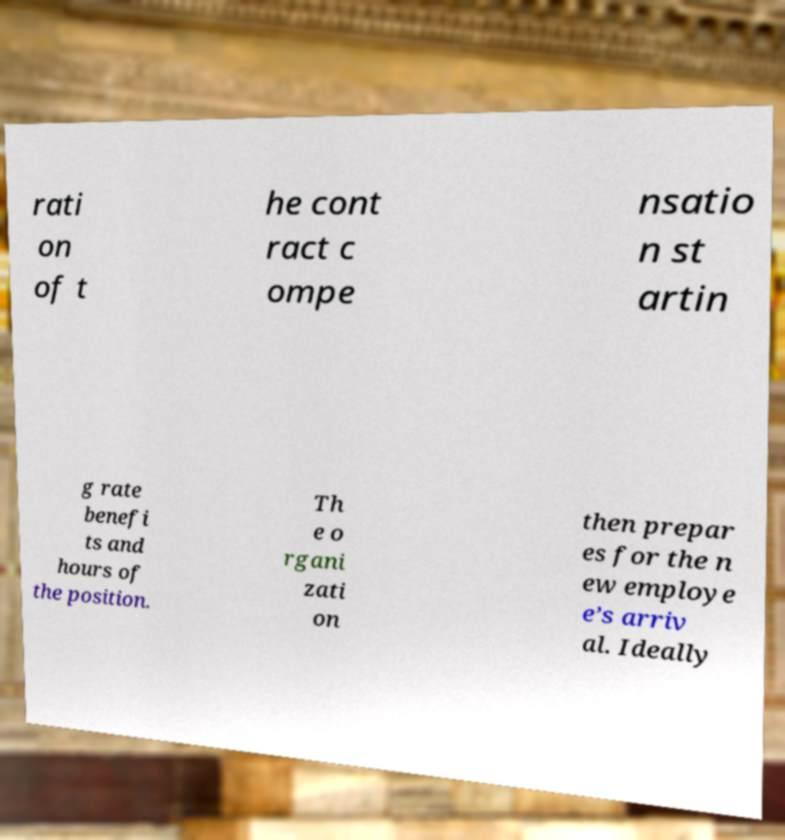I need the written content from this picture converted into text. Can you do that? rati on of t he cont ract c ompe nsatio n st artin g rate benefi ts and hours of the position. Th e o rgani zati on then prepar es for the n ew employe e’s arriv al. Ideally 